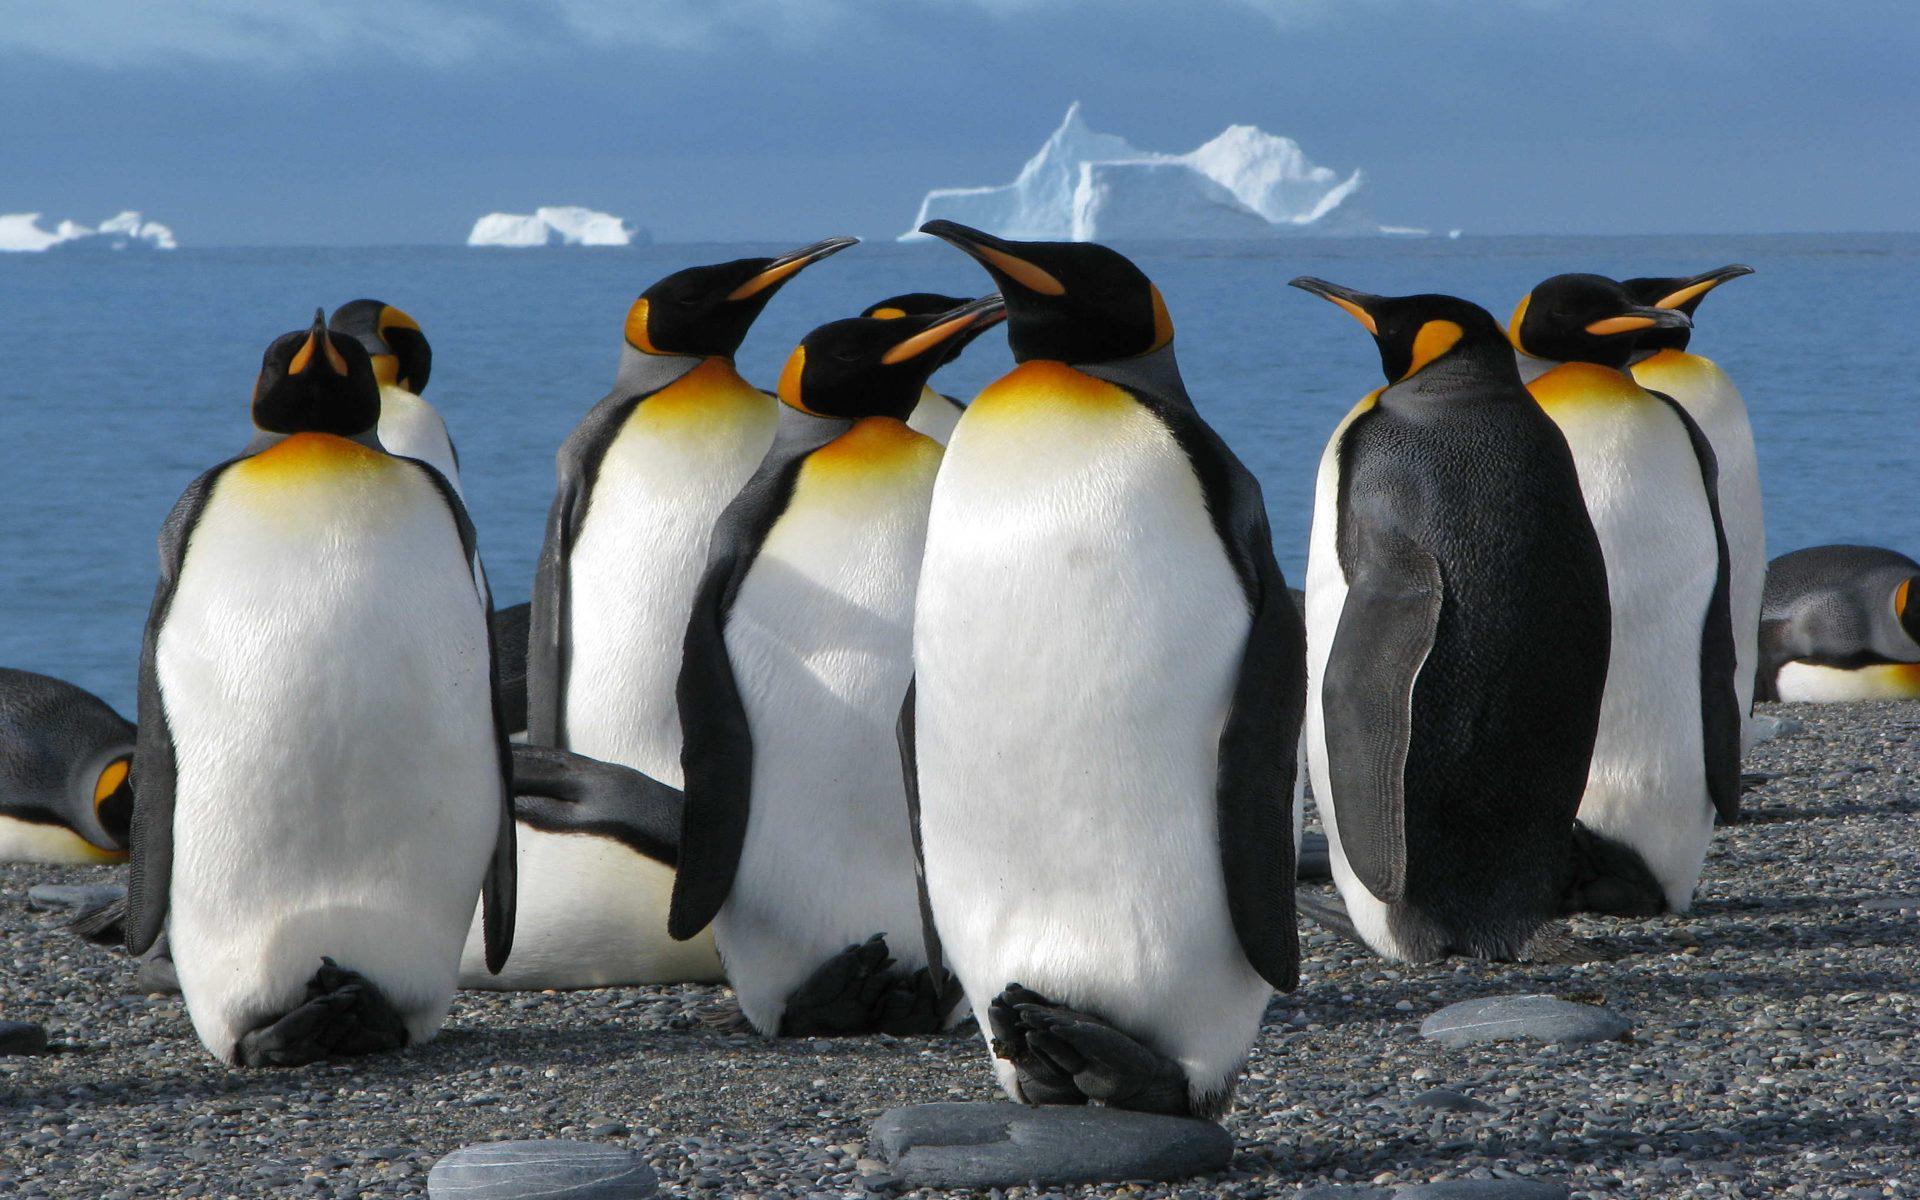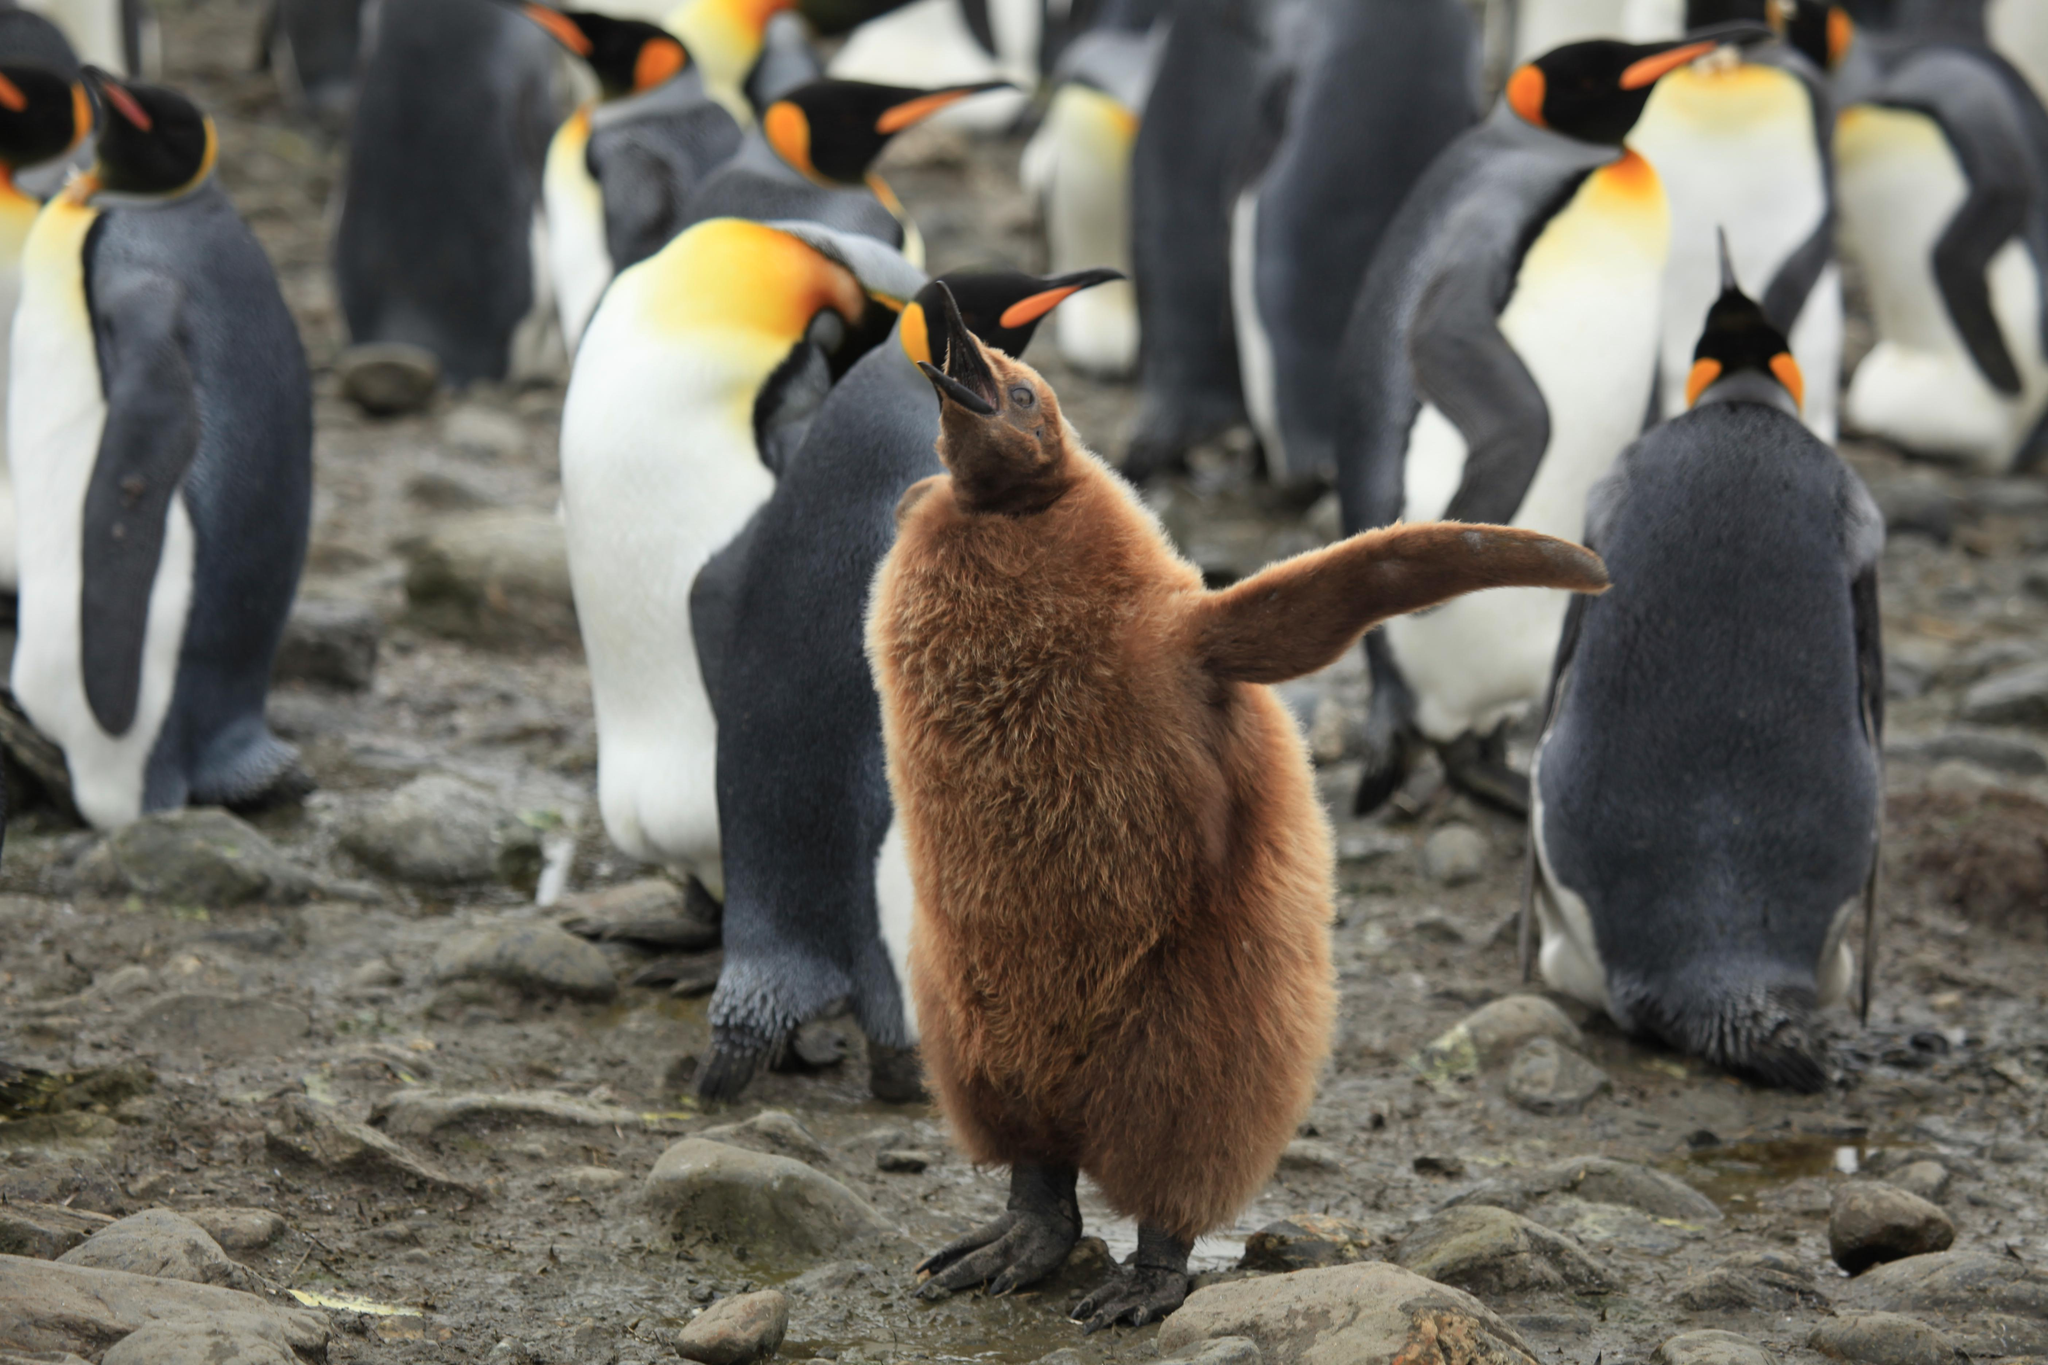The first image is the image on the left, the second image is the image on the right. Evaluate the accuracy of this statement regarding the images: "At least one image shows only two penguins.". Is it true? Answer yes or no. No. The first image is the image on the left, the second image is the image on the right. Given the left and right images, does the statement "One of the pictures has only two penguins." hold true? Answer yes or no. No. 